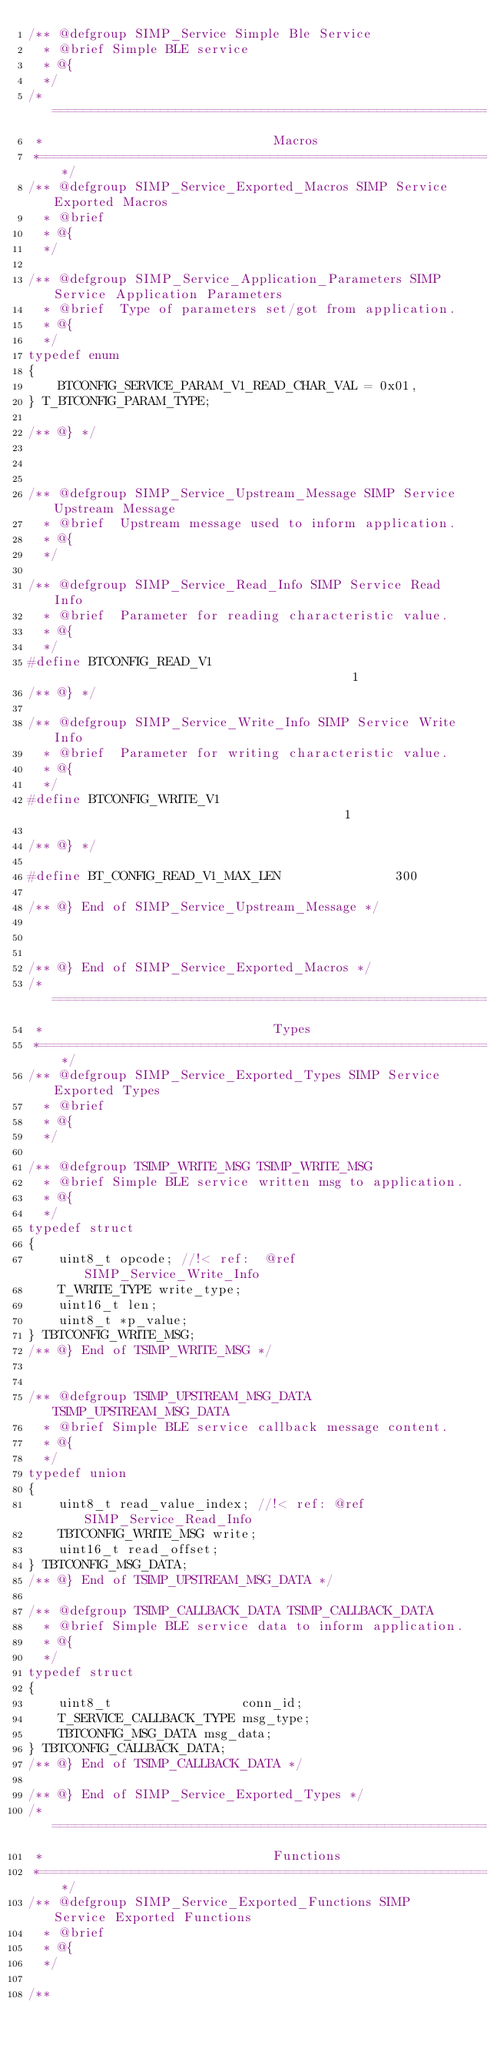<code> <loc_0><loc_0><loc_500><loc_500><_C_>/** @defgroup SIMP_Service Simple Ble Service
  * @brief Simple BLE service
  * @{
  */
/*============================================================================*
 *                              Macros
 *============================================================================*/
/** @defgroup SIMP_Service_Exported_Macros SIMP Service Exported Macros
  * @brief
  * @{
  */

/** @defgroup SIMP_Service_Application_Parameters SIMP Service Application Parameters
  * @brief  Type of parameters set/got from application.
  * @{
  */
typedef enum
{
	BTCONFIG_SERVICE_PARAM_V1_READ_CHAR_VAL = 0x01,
} T_BTCONFIG_PARAM_TYPE;

/** @} */



/** @defgroup SIMP_Service_Upstream_Message SIMP Service Upstream Message
  * @brief  Upstream message used to inform application.
  * @{
  */

/** @defgroup SIMP_Service_Read_Info SIMP Service Read Info
  * @brief  Parameter for reading characteristic value.
  * @{
  */
#define BTCONFIG_READ_V1                                        1
/** @} */

/** @defgroup SIMP_Service_Write_Info SIMP Service Write Info
  * @brief  Parameter for writing characteristic value.
  * @{
  */
#define BTCONFIG_WRITE_V1                                       1

/** @} */

#define BT_CONFIG_READ_V1_MAX_LEN               300

/** @} End of SIMP_Service_Upstream_Message */



/** @} End of SIMP_Service_Exported_Macros */
/*============================================================================*
 *                              Types
 *============================================================================*/
/** @defgroup SIMP_Service_Exported_Types SIMP Service Exported Types
  * @brief
  * @{
  */

/** @defgroup TSIMP_WRITE_MSG TSIMP_WRITE_MSG
  * @brief Simple BLE service written msg to application.
  * @{
  */
typedef struct
{
    uint8_t opcode; //!< ref:  @ref SIMP_Service_Write_Info
    T_WRITE_TYPE write_type;
    uint16_t len;
    uint8_t *p_value;
} TBTCONFIG_WRITE_MSG;
/** @} End of TSIMP_WRITE_MSG */


/** @defgroup TSIMP_UPSTREAM_MSG_DATA TSIMP_UPSTREAM_MSG_DATA
  * @brief Simple BLE service callback message content.
  * @{
  */
typedef union
{
    uint8_t read_value_index; //!< ref: @ref SIMP_Service_Read_Info
    TBTCONFIG_WRITE_MSG write;
	uint16_t read_offset;
} TBTCONFIG_MSG_DATA;
/** @} End of TSIMP_UPSTREAM_MSG_DATA */

/** @defgroup TSIMP_CALLBACK_DATA TSIMP_CALLBACK_DATA
  * @brief Simple BLE service data to inform application.
  * @{
  */
typedef struct
{
    uint8_t                 conn_id;
    T_SERVICE_CALLBACK_TYPE msg_type;
    TBTCONFIG_MSG_DATA msg_data;
} TBTCONFIG_CALLBACK_DATA;
/** @} End of TSIMP_CALLBACK_DATA */

/** @} End of SIMP_Service_Exported_Types */
/*============================================================================*
 *                              Functions
 *============================================================================*/
/** @defgroup SIMP_Service_Exported_Functions SIMP Service Exported Functions
  * @brief
  * @{
  */

/**</code> 